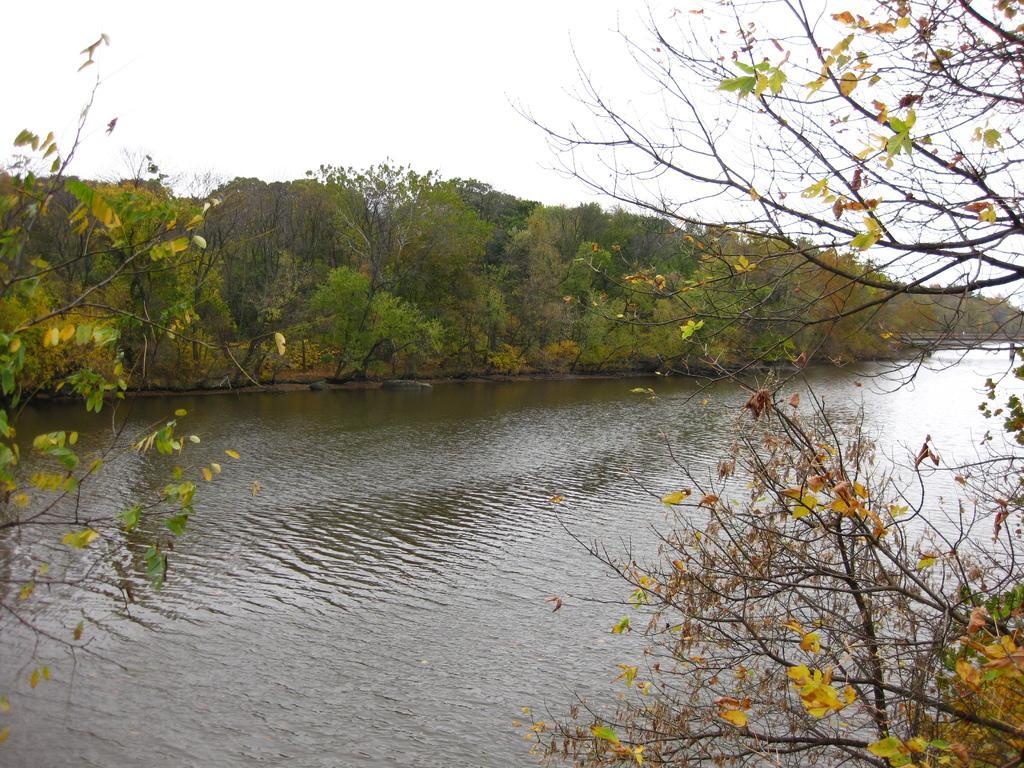Could you give a brief overview of what you see in this image? In this image there are trees. In the middle of the trees there is a water body. In the background there is the sky. 